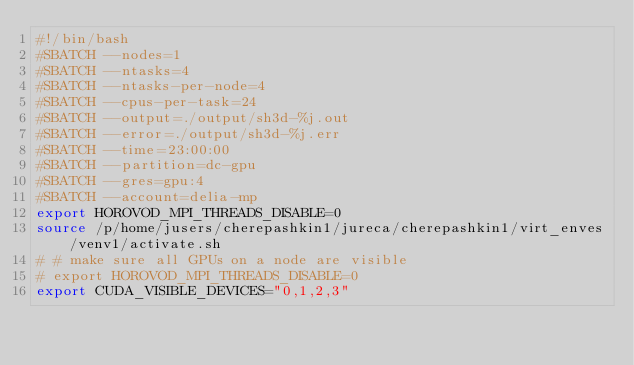Convert code to text. <code><loc_0><loc_0><loc_500><loc_500><_Bash_>#!/bin/bash
#SBATCH --nodes=1
#SBATCH --ntasks=4
#SBATCH --ntasks-per-node=4
#SBATCH --cpus-per-task=24
#SBATCH --output=./output/sh3d-%j.out
#SBATCH --error=./output/sh3d-%j.err
#SBATCH --time=23:00:00
#SBATCH --partition=dc-gpu
#SBATCH --gres=gpu:4
#SBATCH --account=delia-mp
export HOROVOD_MPI_THREADS_DISABLE=0
source /p/home/jusers/cherepashkin1/jureca/cherepashkin1/virt_enves/venv1/activate.sh
# # make sure all GPUs on a node are visible
# export HOROVOD_MPI_THREADS_DISABLE=0
export CUDA_VISIBLE_DEVICES="0,1,2,3"</code> 